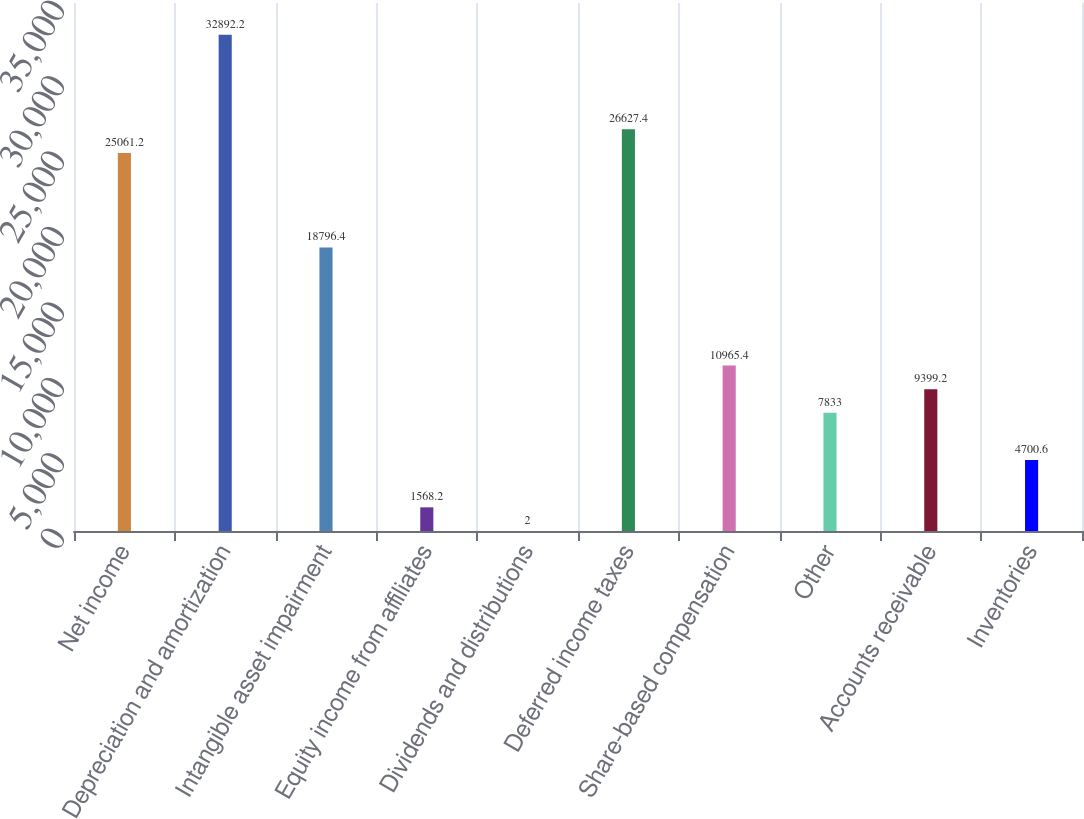Convert chart. <chart><loc_0><loc_0><loc_500><loc_500><bar_chart><fcel>Net income<fcel>Depreciation and amortization<fcel>Intangible asset impairment<fcel>Equity income from affiliates<fcel>Dividends and distributions<fcel>Deferred income taxes<fcel>Share-based compensation<fcel>Other<fcel>Accounts receivable<fcel>Inventories<nl><fcel>25061.2<fcel>32892.2<fcel>18796.4<fcel>1568.2<fcel>2<fcel>26627.4<fcel>10965.4<fcel>7833<fcel>9399.2<fcel>4700.6<nl></chart> 